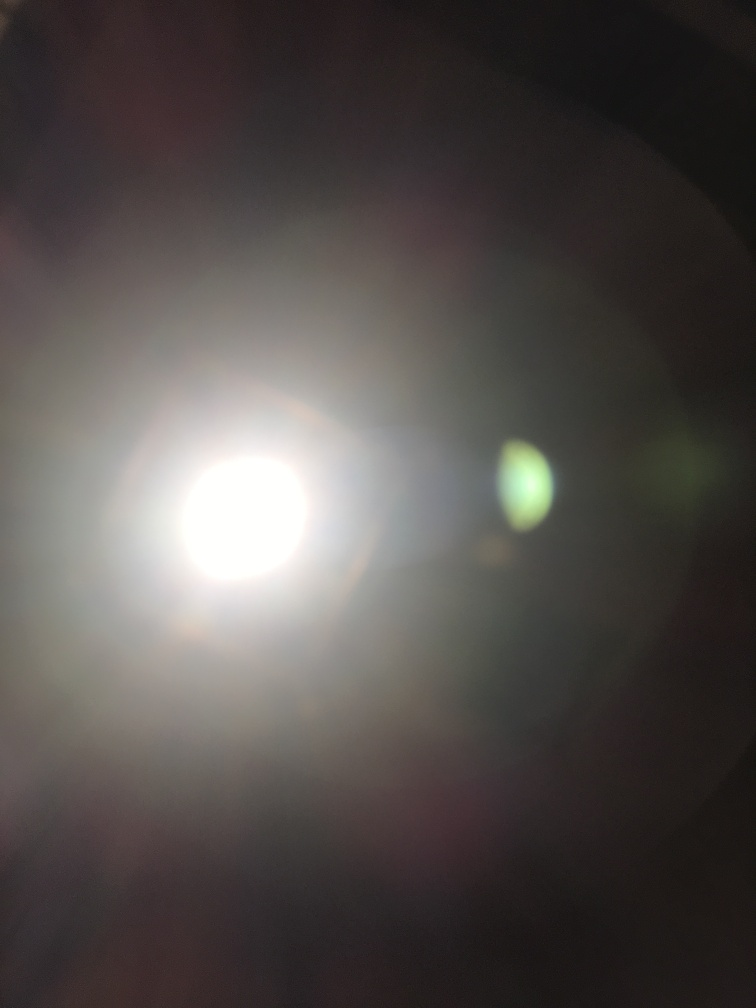Is there anything in the image that could hint at the location where it was taken? Unfortunately, the overexposure in this image washes out any potential details that might hint at the location. Without visible landmarks, environmental cues, or recognizable objects, it's not possible to provide a location based on this image alone. What can be said about the composition of this photograph? Compositionally, this photograph struggles due to the central overexposure, which lacks both focal points and subject definition. Good composition typically guides the viewer's eye through the image and features subjects that are in focus and well-framed. This image might benefit from repositioning the light source, adjusting the focus, and considering the rule of thirds to create a more compelling composition. 